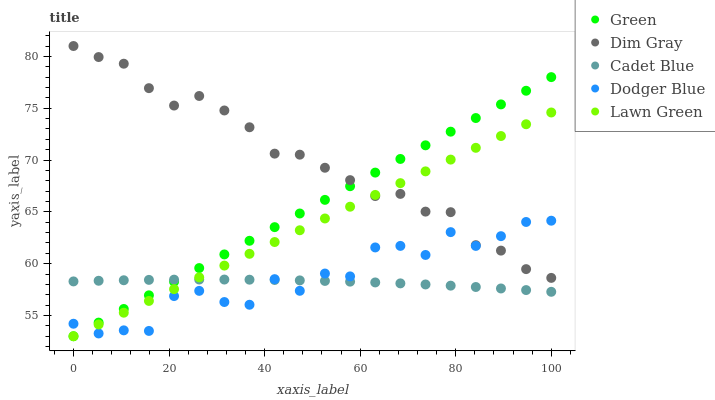Does Cadet Blue have the minimum area under the curve?
Answer yes or no. Yes. Does Dim Gray have the maximum area under the curve?
Answer yes or no. Yes. Does Dodger Blue have the minimum area under the curve?
Answer yes or no. No. Does Dodger Blue have the maximum area under the curve?
Answer yes or no. No. Is Green the smoothest?
Answer yes or no. Yes. Is Dodger Blue the roughest?
Answer yes or no. Yes. Is Dim Gray the smoothest?
Answer yes or no. No. Is Dim Gray the roughest?
Answer yes or no. No. Does Green have the lowest value?
Answer yes or no. Yes. Does Dodger Blue have the lowest value?
Answer yes or no. No. Does Dim Gray have the highest value?
Answer yes or no. Yes. Does Dodger Blue have the highest value?
Answer yes or no. No. Is Cadet Blue less than Dim Gray?
Answer yes or no. Yes. Is Dim Gray greater than Cadet Blue?
Answer yes or no. Yes. Does Green intersect Dodger Blue?
Answer yes or no. Yes. Is Green less than Dodger Blue?
Answer yes or no. No. Is Green greater than Dodger Blue?
Answer yes or no. No. Does Cadet Blue intersect Dim Gray?
Answer yes or no. No. 